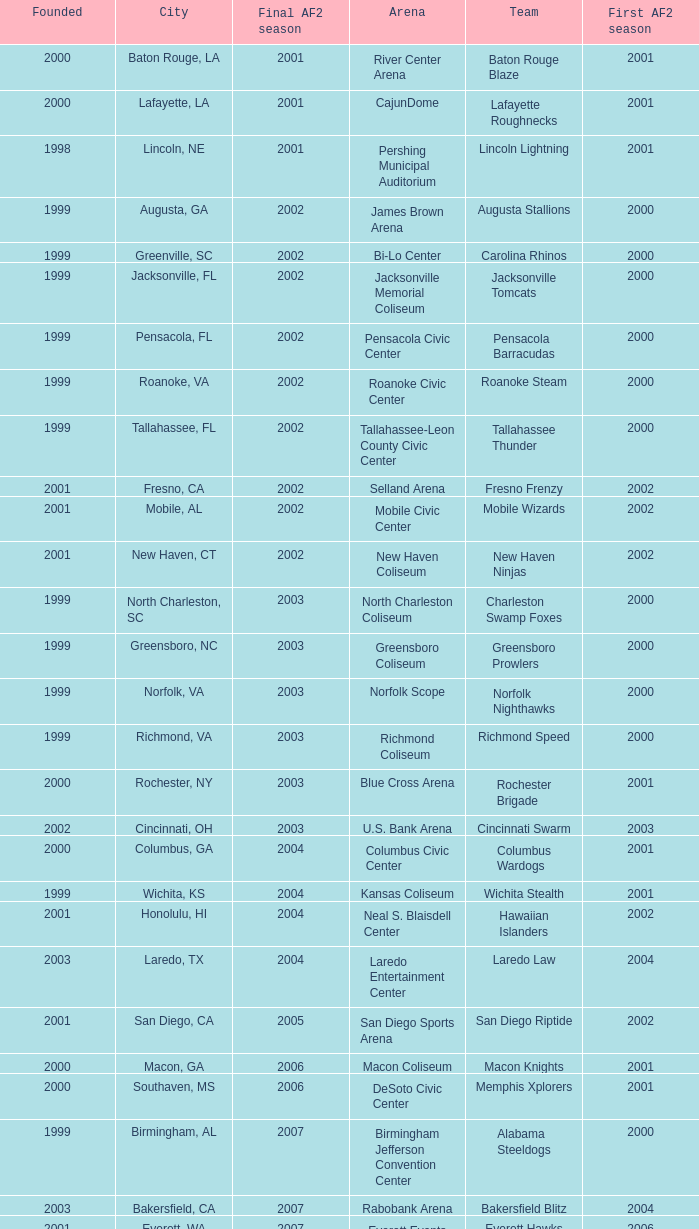How many founded years had a final af2 season prior to 2009 where the arena was the bi-lo center and the first af2 season was prior to 2000? 0.0. 